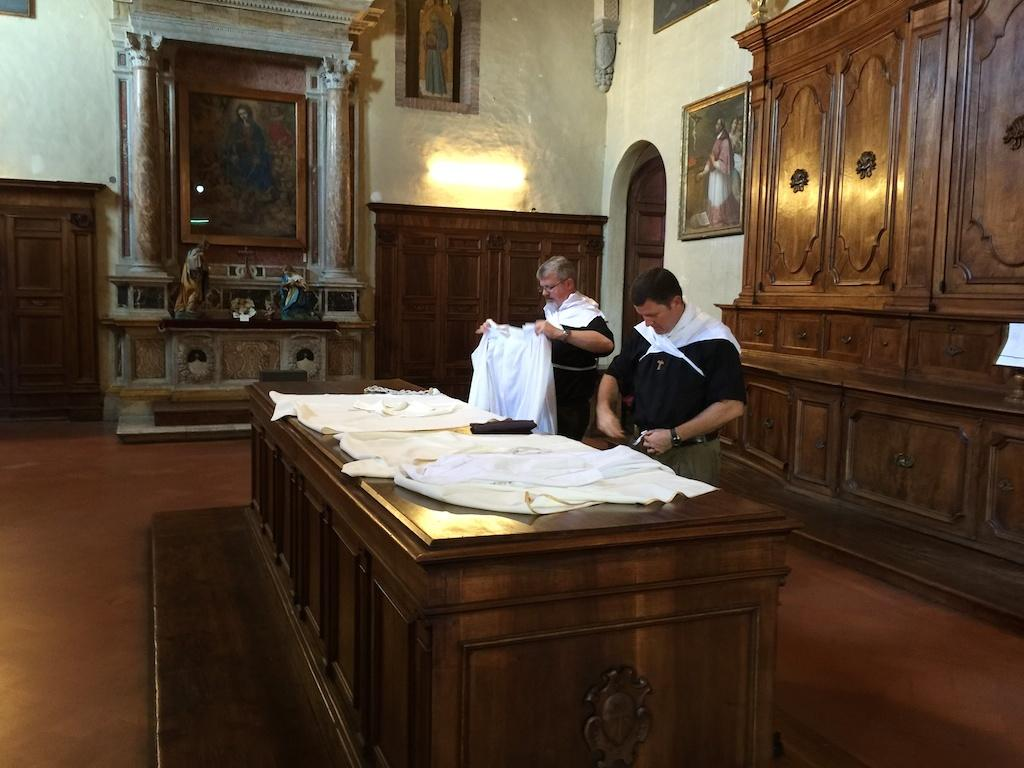How many people are in the image? There are two persons standing in the image. What can be seen on the table in the image? There are clothes on the table. What is attached to the wall in the image? There are frames attached to the wall. What type of furniture is present in the image? There are cupboards in the image. What type of art or decoration is present in the image? There are sculptures in the image. What other objects can be seen in the image? There are other objects present in the image. Can you see the ocean in the image? No, the ocean is not present in the image. 